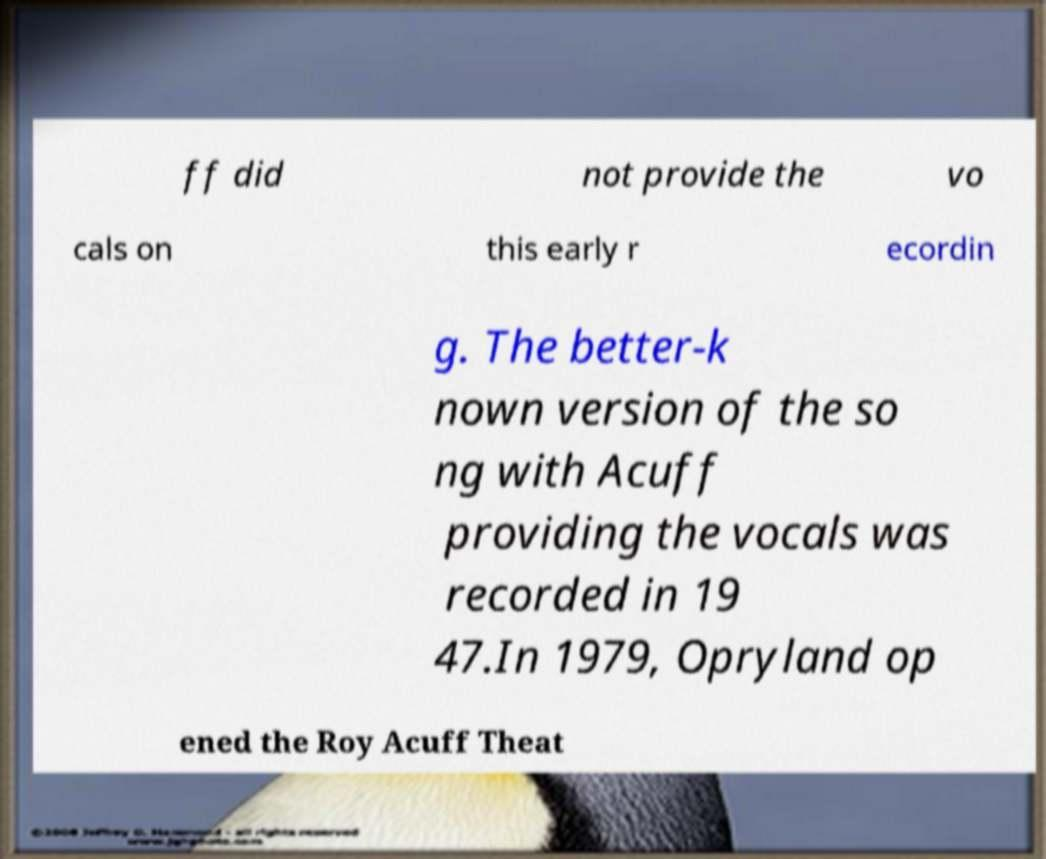Can you read and provide the text displayed in the image?This photo seems to have some interesting text. Can you extract and type it out for me? ff did not provide the vo cals on this early r ecordin g. The better-k nown version of the so ng with Acuff providing the vocals was recorded in 19 47.In 1979, Opryland op ened the Roy Acuff Theat 